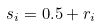Convert formula to latex. <formula><loc_0><loc_0><loc_500><loc_500>s _ { i } = 0 . 5 + r _ { i }</formula> 